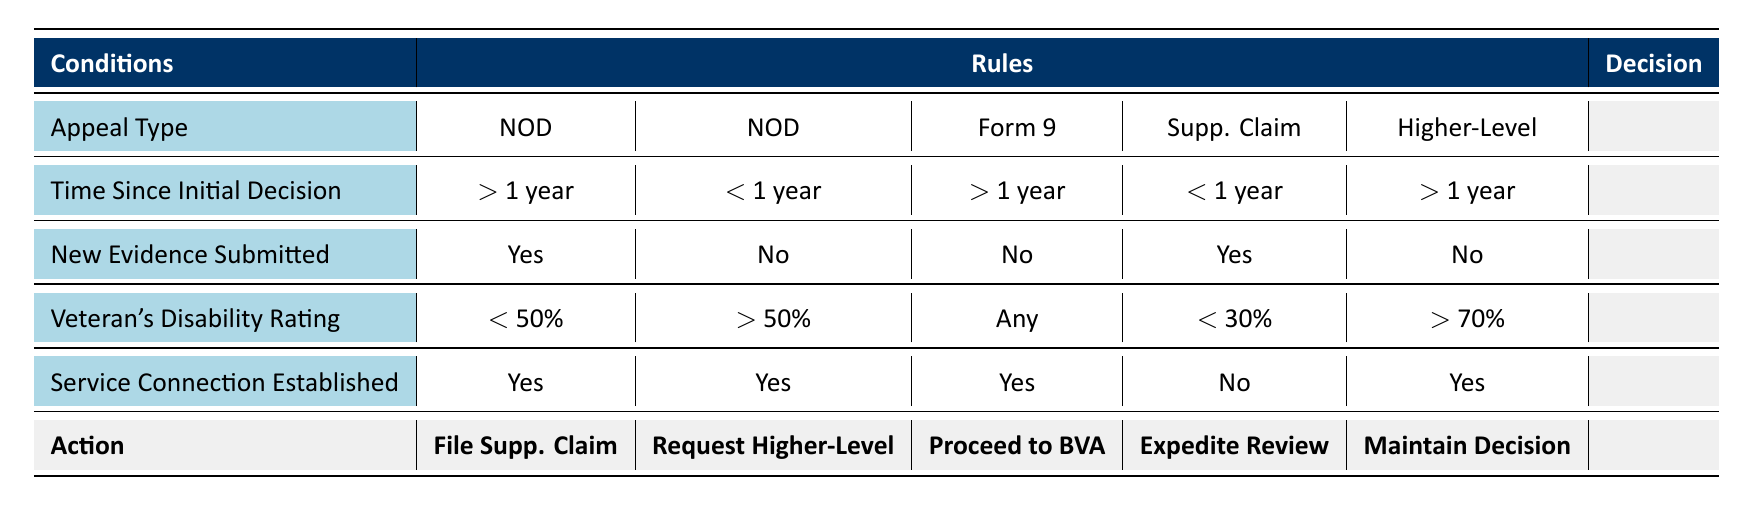What is the decision if the appeal type is a Notice of Disagreement and the time since the initial decision is more than one year? In the table, for the appeal type "Notice of Disagreement" with "Time Since Initial Decision" being greater than 1 year and where new evidence is submitted, the decision is to "File Supplemental Claim."
Answer: File Supplemental Claim If a Supplemental Claim is filed and the Veteran's Disability Rating is less than 30%, what should happen? According to the table, for the Supplemental Claim with a Disability Rating of less than 30% and no Service Connection established, the action is to "Expedite Case Review."
Answer: Expedite Case Review Is it true that if the Veteran's Disability Rating is greater than 70% and the Time Since Initial Decision is more than one year, the original decision will be maintained? Yes, the table indicates that for a Higher-Level Review when the Time Since Initial Decision is more than 1 year and the Disability Rating is greater than 70%, the action is to "Maintain Original Decision."
Answer: Yes What action is taken for a Form 9 appeal if no new evidence is submitted? The table specifies that for a Form 9 when no new evidence is submitted and a Service Connection is established, the decision is to "Proceed to Board of Veterans' Appeals."
Answer: Proceed to Board of Veterans' Appeals If the appeal type is a Notice of Disagreement and the veteran has a rating greater than 50% without new evidence, what is the decision? The table shows that with a Notice of Disagreement, if there is no new evidence and a Veteran's Disability Rating is greater than 50%, the action is to "Request Higher-Level Review."
Answer: Request Higher-Level Review What decision should be made for a Supplemental Claim filed within one year when new evidence is submitted? From the table, for a Supplemental Claim with new evidence submitted within one year and the Service Connection not established, the decision is "Expedite Case Review."
Answer: Expedite Case Review Does the table indicate that filing a Supplemental Claim results in maintaining the original decision if there is unestablished service connection? No, the table states that if a Supplemental Claim is filed with no established Service Connection, the action is to "Expedite Case Review" instead of maintaining the original decision.
Answer: No What are the criteria for proceeding to the Board of Veterans' Appeals? The table lists that to proceed to the Board of Veterans' Appeals, the appeal type must be Form 9, time since the decision greater than one year, and a Service Connection established without any new evidence.
Answer: Form 9, > 1 year, Yes What is the combined knowledge needed to determine whether to expedite a case review? To determine whether to expedite a case review, you need to look for a Supplemental Claim within one year, with new evidence submitted and no established Service Connection.
Answer: Supplemental Claim, within one year, No 